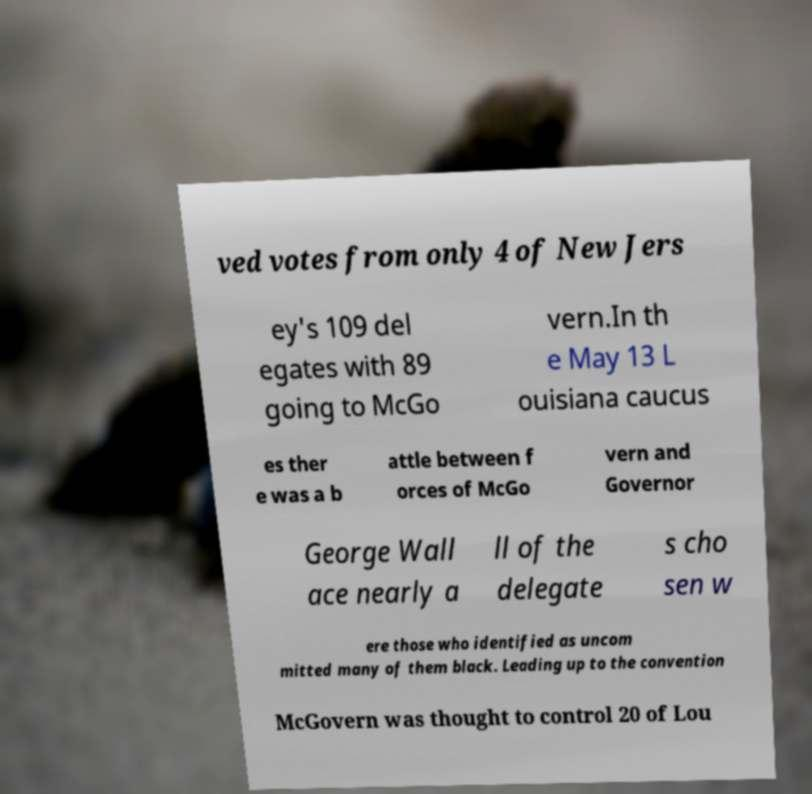I need the written content from this picture converted into text. Can you do that? ved votes from only 4 of New Jers ey's 109 del egates with 89 going to McGo vern.In th e May 13 L ouisiana caucus es ther e was a b attle between f orces of McGo vern and Governor George Wall ace nearly a ll of the delegate s cho sen w ere those who identified as uncom mitted many of them black. Leading up to the convention McGovern was thought to control 20 of Lou 